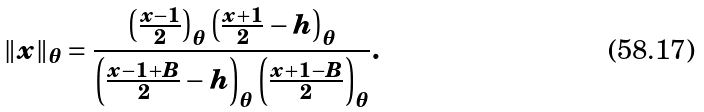Convert formula to latex. <formula><loc_0><loc_0><loc_500><loc_500>\| x \| _ { \theta } = \frac { \left ( \frac { x - 1 } { 2 } \right ) _ { \theta } \left ( \frac { x + 1 } { 2 } - h \right ) _ { \theta } } { \left ( \frac { x - 1 + B } { 2 } - h \right ) _ { \theta } \left ( \frac { x + 1 - B } { 2 } \right ) _ { \theta } } .</formula> 